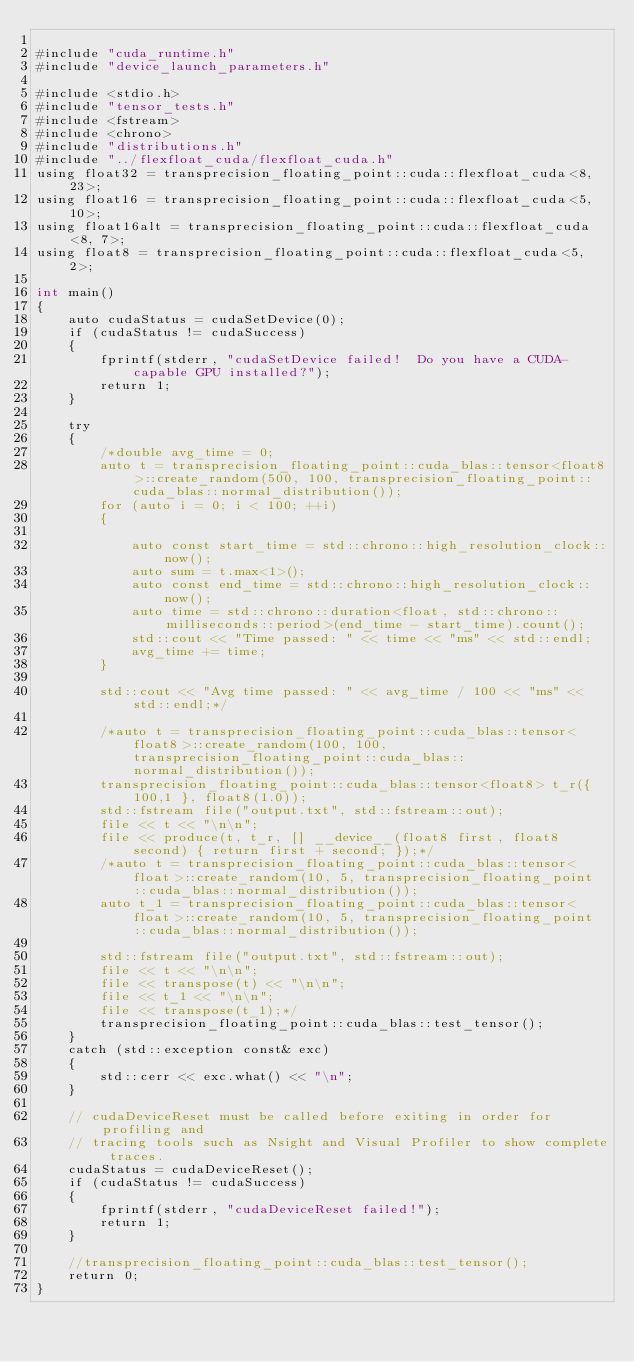Convert code to text. <code><loc_0><loc_0><loc_500><loc_500><_Cuda_>
#include "cuda_runtime.h"
#include "device_launch_parameters.h"

#include <stdio.h>
#include "tensor_tests.h"
#include <fstream>
#include <chrono>
#include "distributions.h"
#include "../flexfloat_cuda/flexfloat_cuda.h"
using float32 = transprecision_floating_point::cuda::flexfloat_cuda<8, 23>;
using float16 = transprecision_floating_point::cuda::flexfloat_cuda<5, 10>;
using float16alt = transprecision_floating_point::cuda::flexfloat_cuda<8, 7>;
using float8 = transprecision_floating_point::cuda::flexfloat_cuda<5, 2>;

int main()
{
	auto cudaStatus = cudaSetDevice(0);
	if (cudaStatus != cudaSuccess)
	{
		fprintf(stderr, "cudaSetDevice failed!  Do you have a CUDA-capable GPU installed?");
		return 1;
	}

	try
	{
		/*double avg_time = 0;
		auto t = transprecision_floating_point::cuda_blas::tensor<float8>::create_random(500, 100, transprecision_floating_point::cuda_blas::normal_distribution());
		for (auto i = 0; i < 100; ++i)
		{

			auto const start_time = std::chrono::high_resolution_clock::now();
			auto sum = t.max<1>();
			auto const end_time = std::chrono::high_resolution_clock::now();
			auto time = std::chrono::duration<float, std::chrono::milliseconds::period>(end_time - start_time).count();
			std::cout << "Time passed: " << time << "ms" << std::endl;
			avg_time += time;
		}

		std::cout << "Avg time passed: " << avg_time / 100 << "ms" << std::endl;*/

		/*auto t = transprecision_floating_point::cuda_blas::tensor<float8>::create_random(100, 100, transprecision_floating_point::cuda_blas::normal_distribution());
		transprecision_floating_point::cuda_blas::tensor<float8> t_r({ 100,1 }, float8(1.0));
		std::fstream file("output.txt", std::fstream::out);
		file << t << "\n\n";
		file << produce(t, t_r, [] __device__(float8 first, float8 second) { return first + second; });*/
		/*auto t = transprecision_floating_point::cuda_blas::tensor<float>::create_random(10, 5, transprecision_floating_point::cuda_blas::normal_distribution());
		auto t_1 = transprecision_floating_point::cuda_blas::tensor<float>::create_random(10, 5, transprecision_floating_point::cuda_blas::normal_distribution());
		
		std::fstream file("output.txt", std::fstream::out);
		file << t << "\n\n";
		file << transpose(t) << "\n\n";
		file << t_1 << "\n\n";
		file << transpose(t_1);*/
		transprecision_floating_point::cuda_blas::test_tensor();
	}
	catch (std::exception const& exc)
	{
		std::cerr << exc.what() << "\n";
	}

	// cudaDeviceReset must be called before exiting in order for profiling and
	// tracing tools such as Nsight and Visual Profiler to show complete traces.
	cudaStatus = cudaDeviceReset();
	if (cudaStatus != cudaSuccess)
	{
		fprintf(stderr, "cudaDeviceReset failed!");
		return 1;
	}

	//transprecision_floating_point::cuda_blas::test_tensor();
	return 0;
}
</code> 